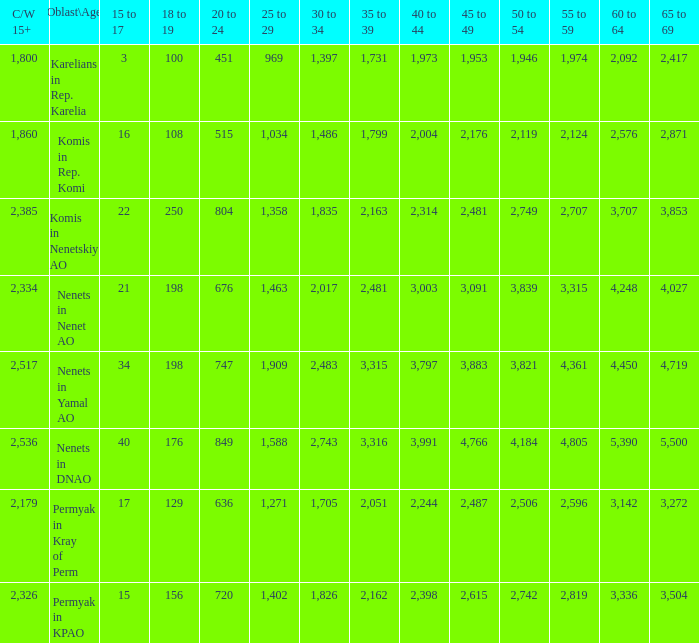What is the mean 55 to 59 when the C/W 15+ is greater than 2,385, and the 30 to 34 is 2,483, and the 35 to 39 is greater than 3,315? None. 